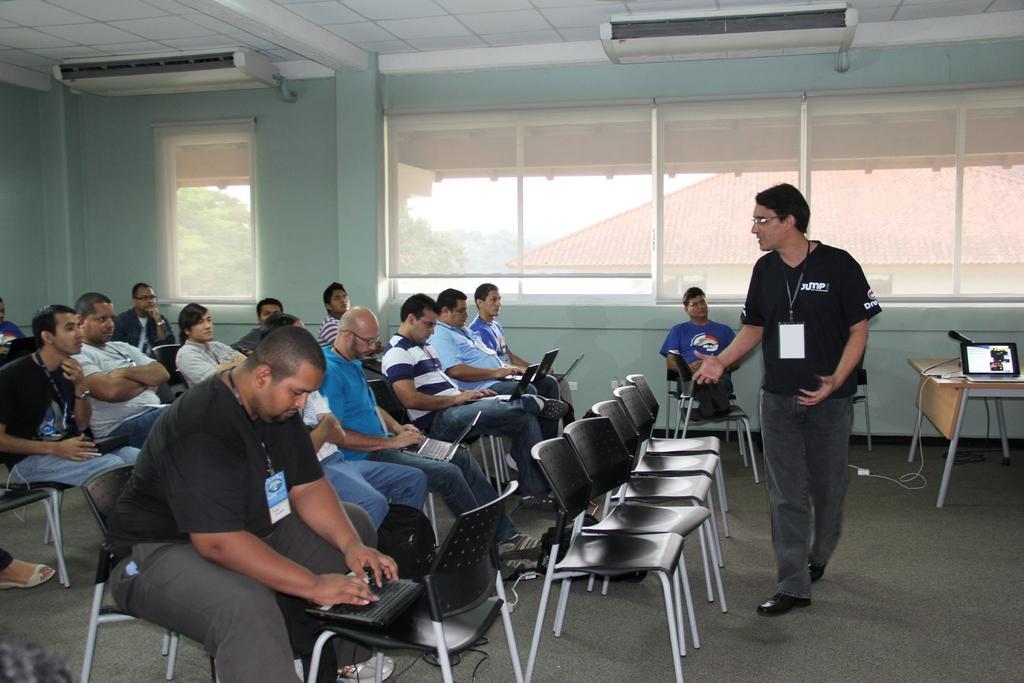In one or two sentences, can you explain what this image depicts? In the middle of the image few people are sitting on the chairs and few people are also using laptops. In the middle of the image a man is standing. Bottom right side of the image there is a table, On the table there is a laptop. Behind the laptop there is a microphone. In the middle of the image there is a glass window. Through the glass window we can see a building and there is a sky and there are some trees. At the top of the image there is a roof. 